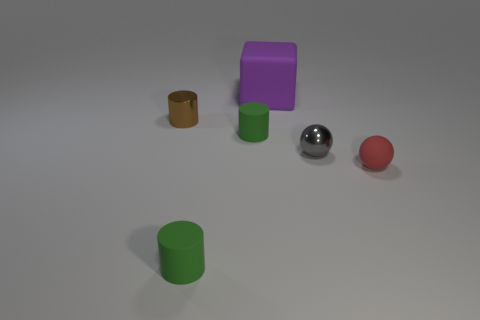There is a green thing that is to the right of the matte thing in front of the tiny red thing; how many small brown things are in front of it?
Ensure brevity in your answer.  0. Does the green matte object behind the gray metallic sphere have the same shape as the rubber object that is to the right of the big rubber cube?
Your answer should be very brief. No. How many things are spheres or tiny brown objects?
Keep it short and to the point. 3. There is a small green thing that is in front of the tiny object that is on the right side of the gray metallic sphere; what is its material?
Your answer should be compact. Rubber. Is there another sphere of the same color as the tiny shiny sphere?
Offer a terse response. No. There is a shiny thing that is the same size as the metallic cylinder; what is its color?
Your answer should be very brief. Gray. What material is the green cylinder in front of the green thing behind the metallic thing that is right of the big cube?
Offer a very short reply. Rubber. There is a tiny matte ball; is its color the same as the tiny cylinder in front of the small metallic ball?
Offer a terse response. No. What number of objects are either things on the right side of the large purple thing or shiny things that are on the left side of the large purple block?
Offer a terse response. 3. What is the shape of the green rubber thing on the right side of the rubber cylinder in front of the metallic sphere?
Give a very brief answer. Cylinder. 